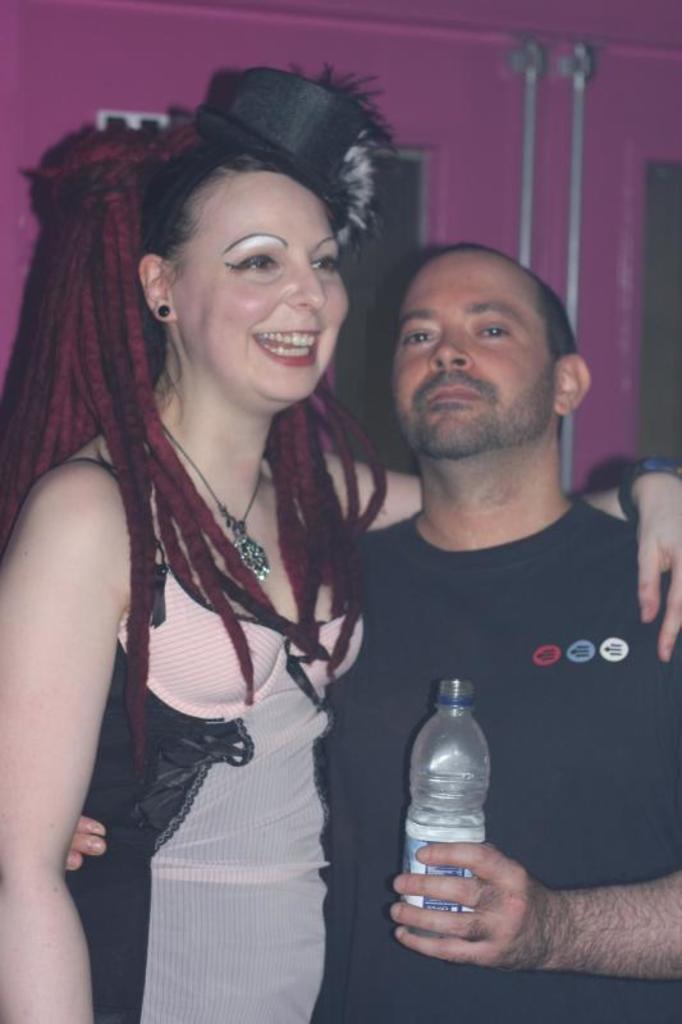In one or two sentences, can you explain what this image depicts? This picture shows a man and a woman standing and a man holding a water bottle in his hand 